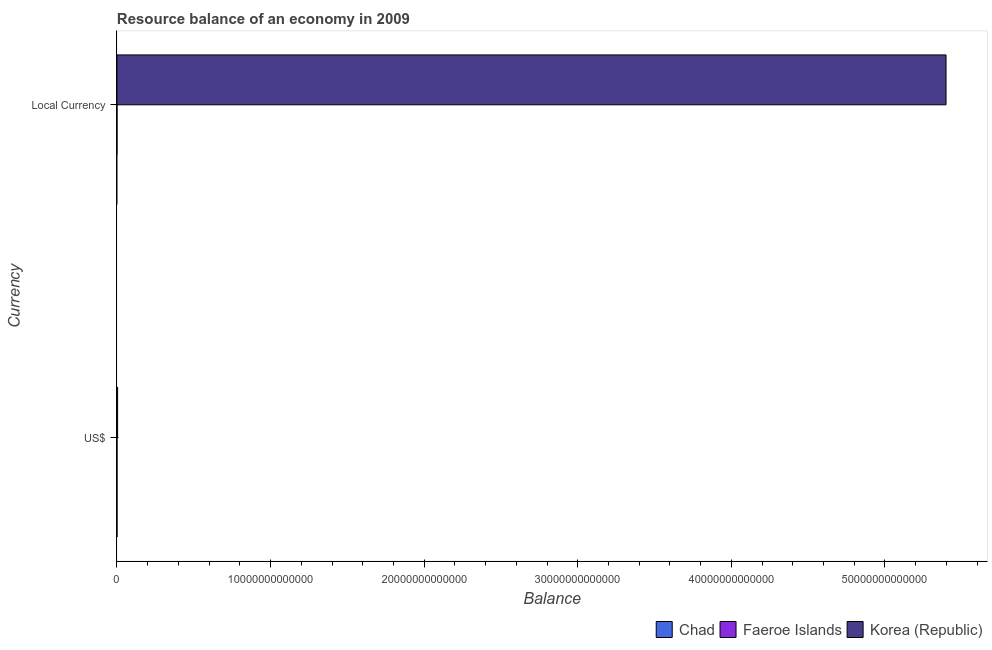How many bars are there on the 1st tick from the top?
Offer a very short reply. 1. How many bars are there on the 2nd tick from the bottom?
Your answer should be compact. 1. What is the label of the 2nd group of bars from the top?
Provide a succinct answer. US$. What is the resource balance in us$ in Korea (Republic)?
Provide a succinct answer. 4.23e+1. Across all countries, what is the maximum resource balance in constant us$?
Provide a short and direct response. 5.40e+13. Across all countries, what is the minimum resource balance in us$?
Your answer should be very brief. 0. What is the total resource balance in constant us$ in the graph?
Offer a terse response. 5.40e+13. What is the average resource balance in us$ per country?
Provide a succinct answer. 1.41e+1. What is the difference between the resource balance in us$ and resource balance in constant us$ in Korea (Republic)?
Offer a terse response. -5.39e+13. In how many countries, is the resource balance in us$ greater than 48000000000000 units?
Your answer should be very brief. 0. How many bars are there?
Make the answer very short. 2. What is the difference between two consecutive major ticks on the X-axis?
Give a very brief answer. 1.00e+13. Are the values on the major ticks of X-axis written in scientific E-notation?
Give a very brief answer. No. Does the graph contain any zero values?
Keep it short and to the point. Yes. Where does the legend appear in the graph?
Provide a succinct answer. Bottom right. What is the title of the graph?
Keep it short and to the point. Resource balance of an economy in 2009. What is the label or title of the X-axis?
Provide a succinct answer. Balance. What is the label or title of the Y-axis?
Give a very brief answer. Currency. What is the Balance of Chad in US$?
Make the answer very short. 0. What is the Balance of Korea (Republic) in US$?
Offer a terse response. 4.23e+1. What is the Balance in Chad in Local Currency?
Make the answer very short. 0. What is the Balance in Faeroe Islands in Local Currency?
Your answer should be very brief. 0. What is the Balance in Korea (Republic) in Local Currency?
Keep it short and to the point. 5.40e+13. Across all Currency, what is the maximum Balance of Korea (Republic)?
Your response must be concise. 5.40e+13. Across all Currency, what is the minimum Balance in Korea (Republic)?
Offer a terse response. 4.23e+1. What is the total Balance in Chad in the graph?
Make the answer very short. 0. What is the total Balance of Faeroe Islands in the graph?
Give a very brief answer. 0. What is the total Balance in Korea (Republic) in the graph?
Your response must be concise. 5.40e+13. What is the difference between the Balance of Korea (Republic) in US$ and that in Local Currency?
Offer a very short reply. -5.39e+13. What is the average Balance of Faeroe Islands per Currency?
Provide a short and direct response. 0. What is the average Balance of Korea (Republic) per Currency?
Offer a very short reply. 2.70e+13. What is the ratio of the Balance in Korea (Republic) in US$ to that in Local Currency?
Provide a short and direct response. 0. What is the difference between the highest and the second highest Balance of Korea (Republic)?
Offer a very short reply. 5.39e+13. What is the difference between the highest and the lowest Balance in Korea (Republic)?
Provide a short and direct response. 5.39e+13. 